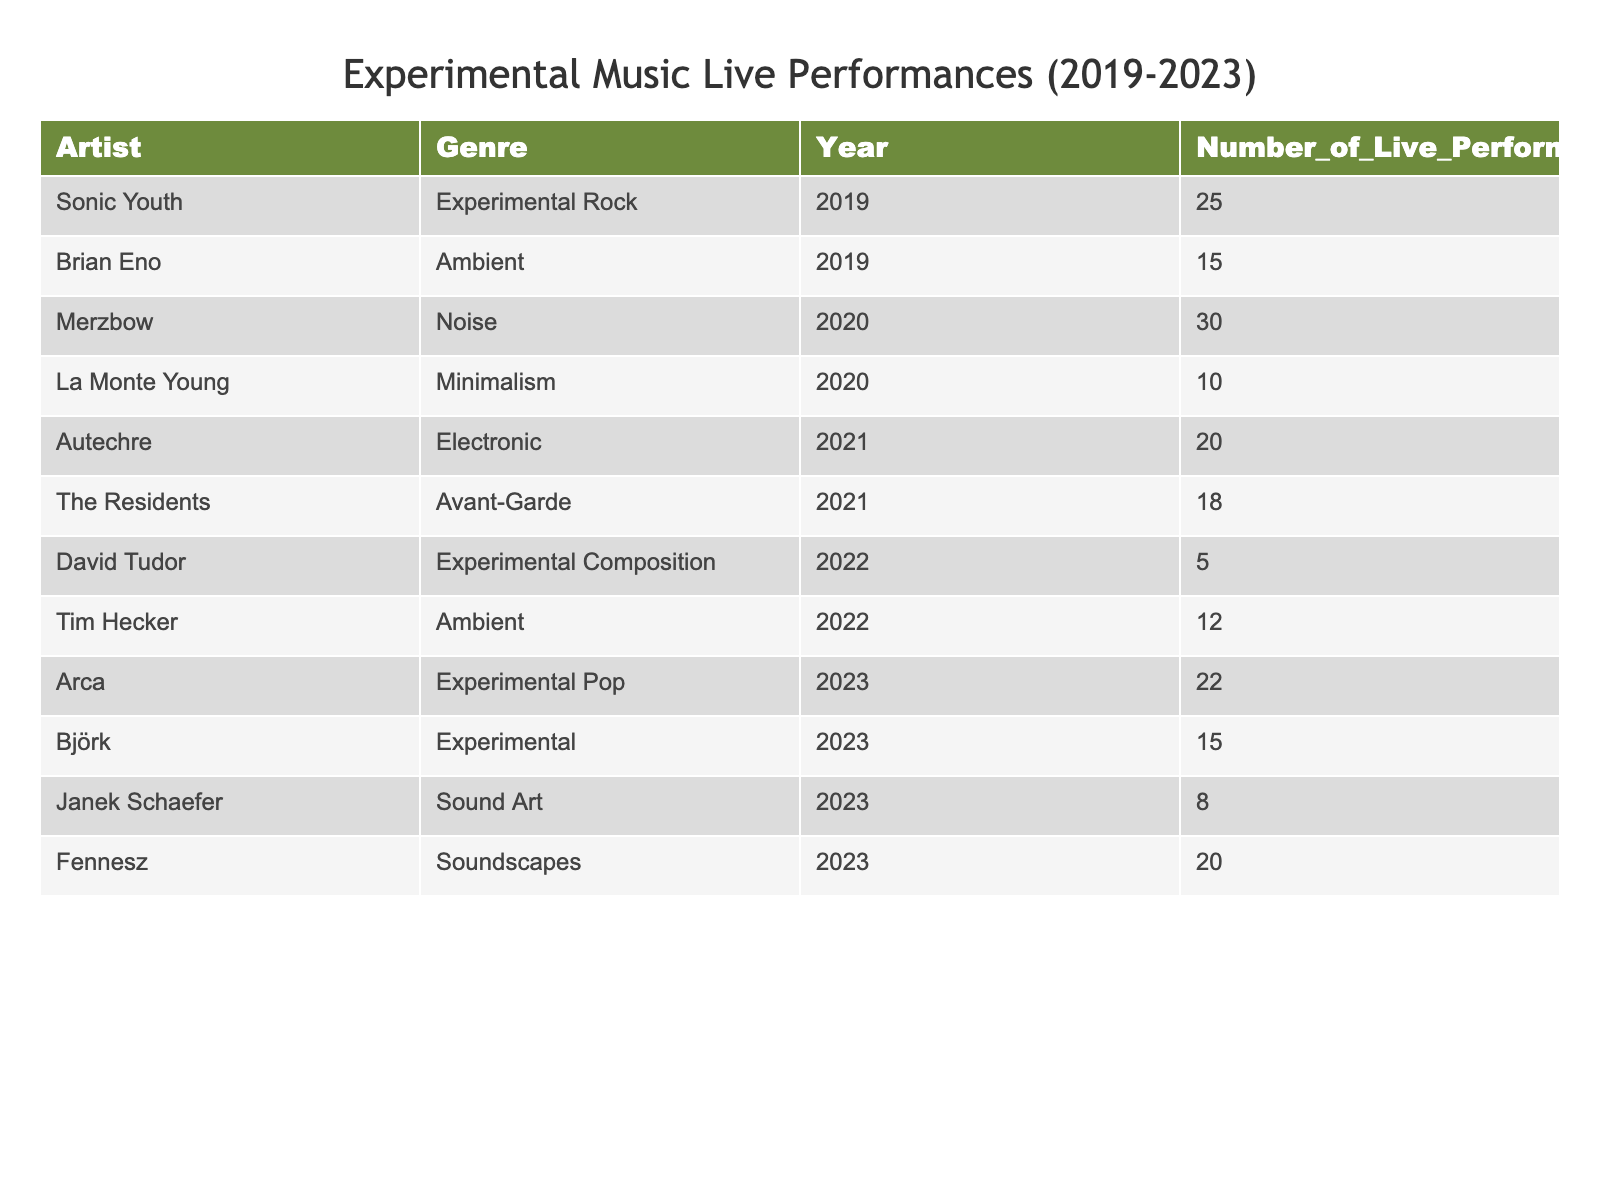What is the total number of live performances by all artists in 2023? To find the total for 2023, sum the values of live performances for the artists listed for that year: Arca (22), Björk (15), Janek Schaefer (8), and Fennesz (20). Adding these gives 22 + 15 + 8 + 20 = 65.
Answer: 65 Which artist had the highest number of live performances in 2020? Looking at the data for the year 2020, Merzbow had 30 performances, and La Monte Young had 10. Clearly, the highest number is from Merzbow with 30 performances.
Answer: Merzbow Is it true that Sonic Youth performed more live shows than Autechre? Sonic Youth had 25 live performances in 2019, while Autechre had 20 performances in 2021. Since 25 is greater than 20, the statement is true.
Answer: Yes What is the average number of live performances across all artists for the year 2021? For 2021, the artists and their performances are Autechre (20) and The Residents (18). Sum these: 20 + 18 = 38. There are 2 artists, so the average is 38/2 = 19.
Answer: 19 Which genre had the least number of live performances total across the five years? Adding up the performances by genre: Ambient (15 + 12), Minimalism (10), Experimental Pop (22), Experimental Rock (25), Noise (30), Avant-Garde (18), Experimental Composition (5), Sound Art (8), Soundscapes (20). The least is Experimental Composition with a total of 5.
Answer: Experimental Composition How many more performances did Merzbow have than David Tudor? Merzbow had 30 performances in 2020, and David Tudor had 5 performances in 2022. The difference is 30 - 5 = 25, meaning Merzbow had 25 more performances than Tudor.
Answer: 25 Which year saw the least number of live performances in total? Summing the total performances by year: 2019 (40), 2020 (40), 2021 (38), 2022 (17), 2023 (65). The least total is from 2022 with 17 performances.
Answer: 2022 Did any artist perform more than 20 times in 2022? In 2022, the performances listed are David Tudor (5) and Tim Hecker (12). Since both values are below 20, there were no artists performing more than 20 times that year.
Answer: No How many artists have performed in more than one year? Sonic Youth (2019), Brian Eno (2019), Merzbow (2020), La Monte Young (2020), Autechre (2021), The Residents (2021), David Tudor (2022), Tim Hecker (2022), Arca (2023), Björk (2023), Janek Schaefer (2023), and Fennesz (2023). The count reveals that there are two artists (David Tudor and Tim Hecker), hence the answer is one.
Answer: One 